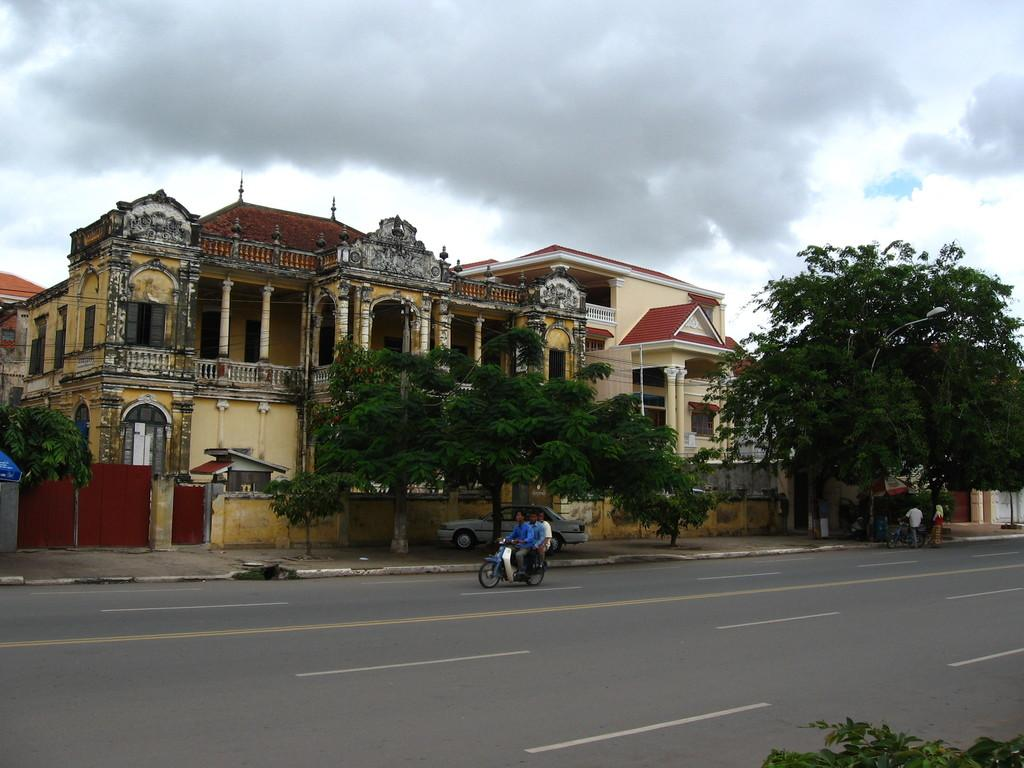How many people are on the bike in the image? There are three persons on the bike in the image. Where is the bike located? The bike is on the road in the image. What can be seen in the background of the image? There are trees, buildings, and the sky visible in the background of the image. What is the condition of the sky in the image? The sky is visible with clouds in the background of the image. What type of pain is the person on the bike experiencing in the image? There is no indication of pain or discomfort experienced by any person in the image. 